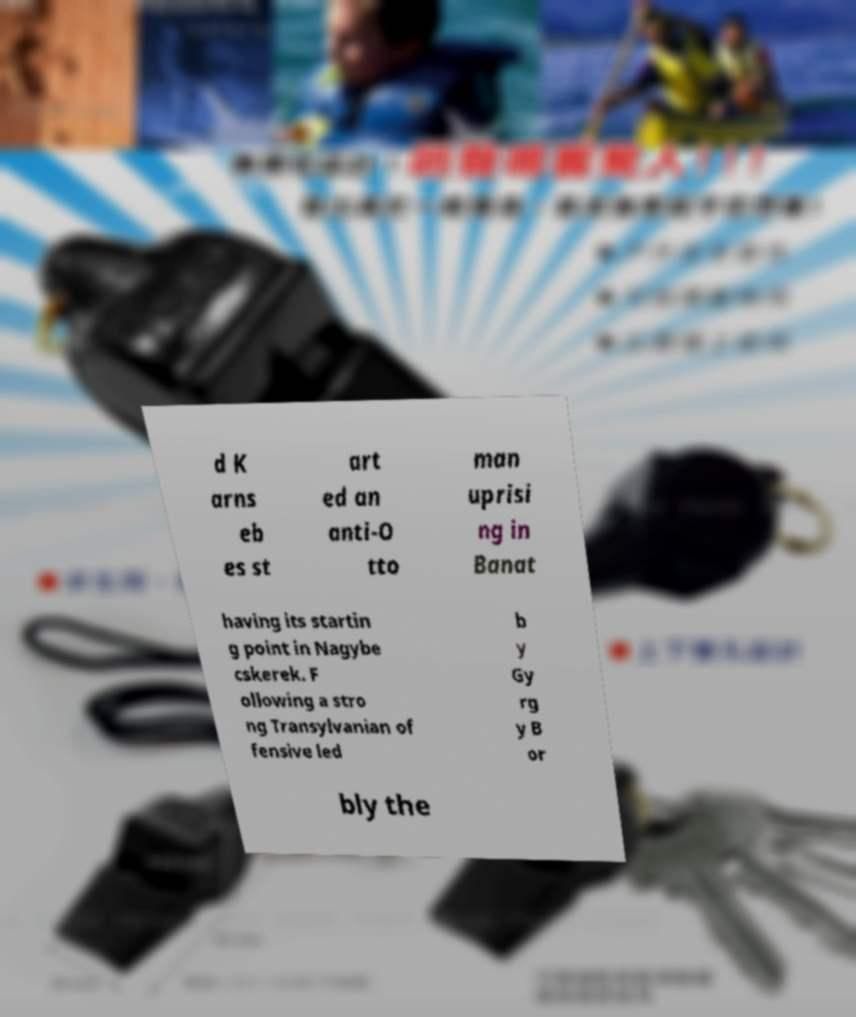For documentation purposes, I need the text within this image transcribed. Could you provide that? d K arns eb es st art ed an anti-O tto man uprisi ng in Banat having its startin g point in Nagybe cskerek. F ollowing a stro ng Transylvanian of fensive led b y Gy rg y B or bly the 